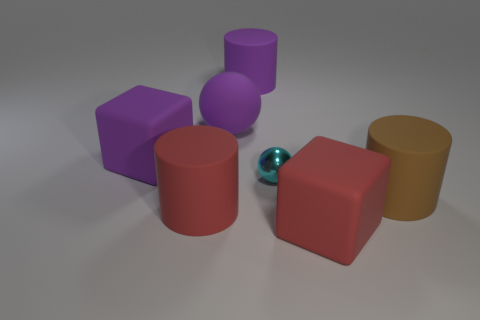Add 1 cubes. How many objects exist? 8 Subtract all blocks. How many objects are left? 5 Subtract all purple objects. Subtract all red things. How many objects are left? 2 Add 7 big purple cylinders. How many big purple cylinders are left? 8 Add 4 cyan spheres. How many cyan spheres exist? 5 Subtract 0 brown balls. How many objects are left? 7 